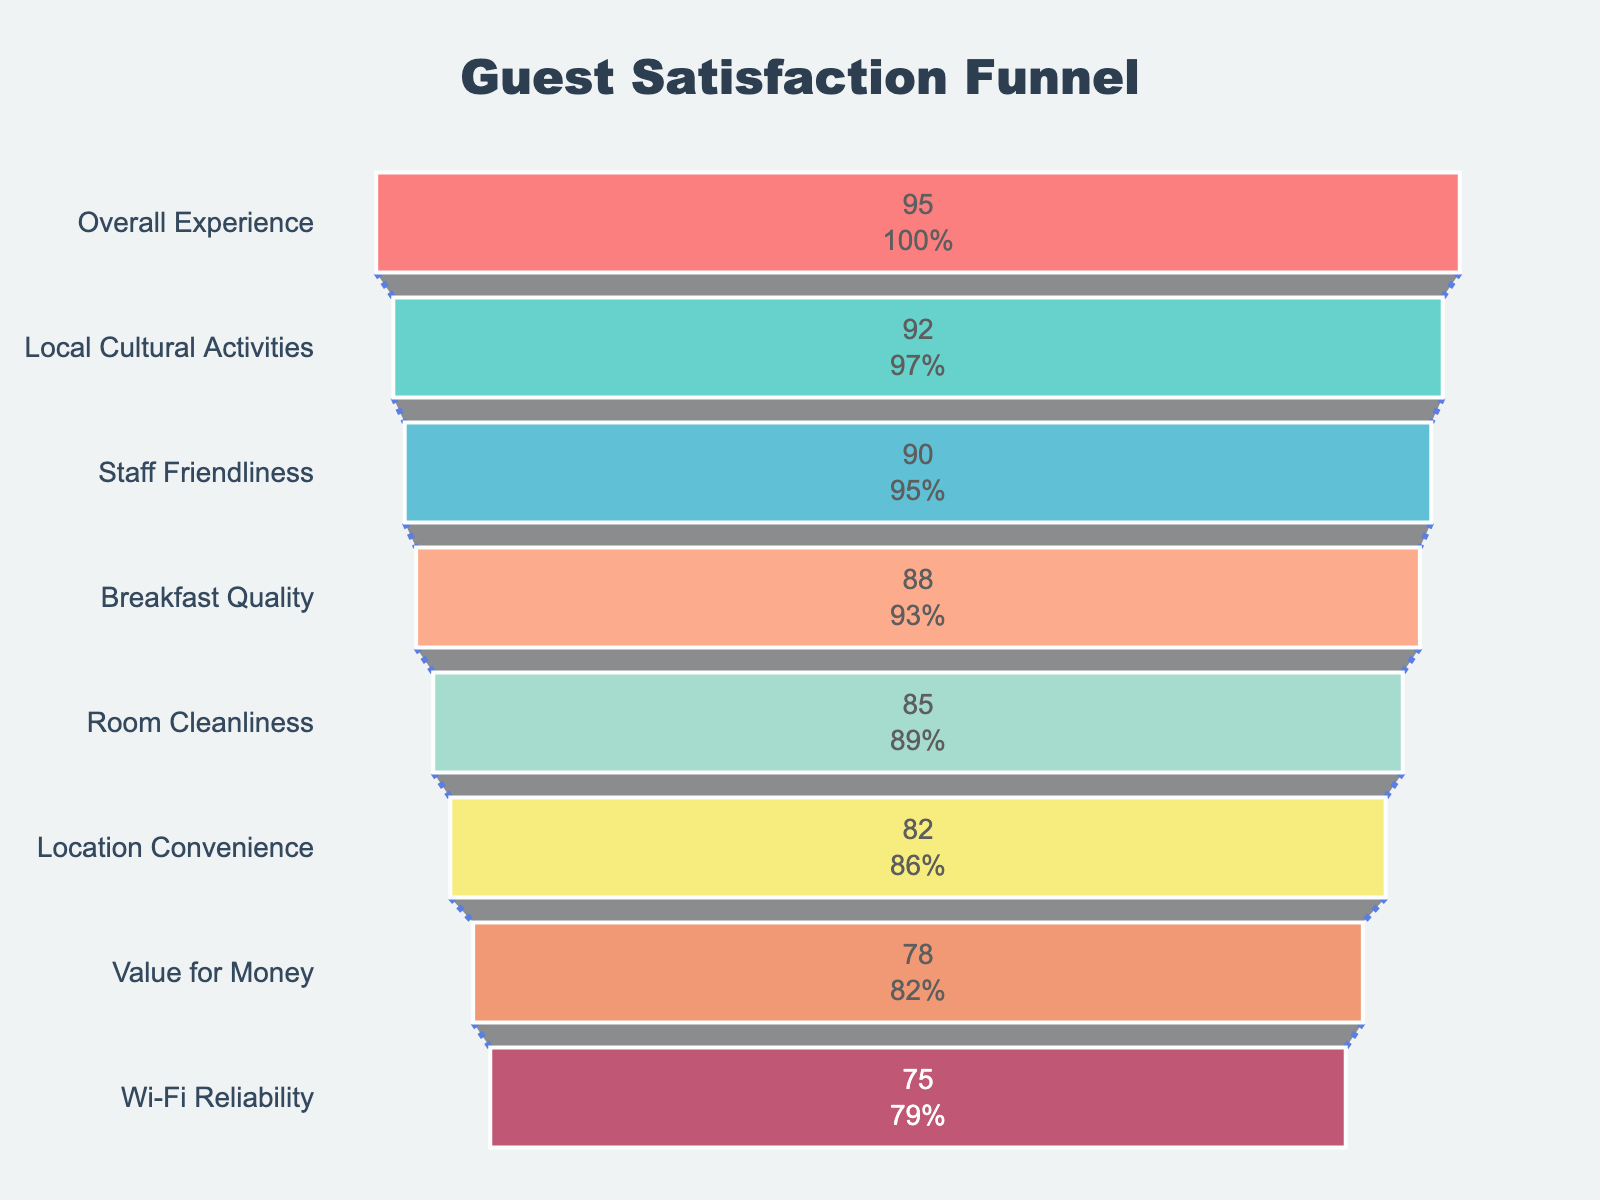What is the title of the plot? The title is located at the top of the plot. It is usually displayed in a larger font size compared to other text elements and provides a brief summary of what the plot represents.
Answer: Guest Satisfaction Funnel How many aspects of the stay are evaluated in the plot? You can count the number of horizontal bars in the funnel to determine the number of evaluated aspects.
Answer: 8 Which aspect received the highest satisfaction score? Look at the funnel chart’s first section at the top, which represents the aspect with the highest satisfaction score.
Answer: Overall Experience What is the satisfaction score for Wi-Fi Reliability? Locate the bar labeled “Wi-Fi Reliability” and read the associated score displayed inside the funnel.
Answer: 75 Which aspect has the lowest satisfaction score? Look at the funnel chart’s last section at the bottom, which represents the aspect with the lowest satisfaction score.
Answer: Wi-Fi Reliability What is the difference in satisfaction scores between Staff Friendliness and Room Cleanliness? Find the scores for both Staff Friendliness (90) and Room Cleanliness (85). Subtract the score of Room Cleanliness from Staff Friendliness.
Answer: 5 Are there any aspects with a satisfaction score above 90? Check the bars to see which aspects have scores greater than 90. The first two aspects are key to answering this.
Answer: 2 What is the average satisfaction score for Breakfast Quality, Room Cleanliness, and Location Convenience? Find the scores for Breakfast Quality (88), Room Cleanliness (85), and Location Convenience (82). Add these scores and divide by 3 to find the average: (88 + 85 + 82) / 3
Answer: 85 Which aspects have satisfaction scores greater than or equal to 85 but less than 90? Determine the scores for each aspect and identify those within the specified range. In this case, check Room Cleanliness (85).
Answer: Room Cleanliness What percentage of the initial satisfaction score does the last bar represent in the chart? Percentage inside the funnel typically uses the score of the first bar as the basis (100%). For Wi-Fi Reliability (75), you need to compare it with the Overall Experience (95): (75/95)*100 ≈ 78.95%
Answer: ~78.95% 